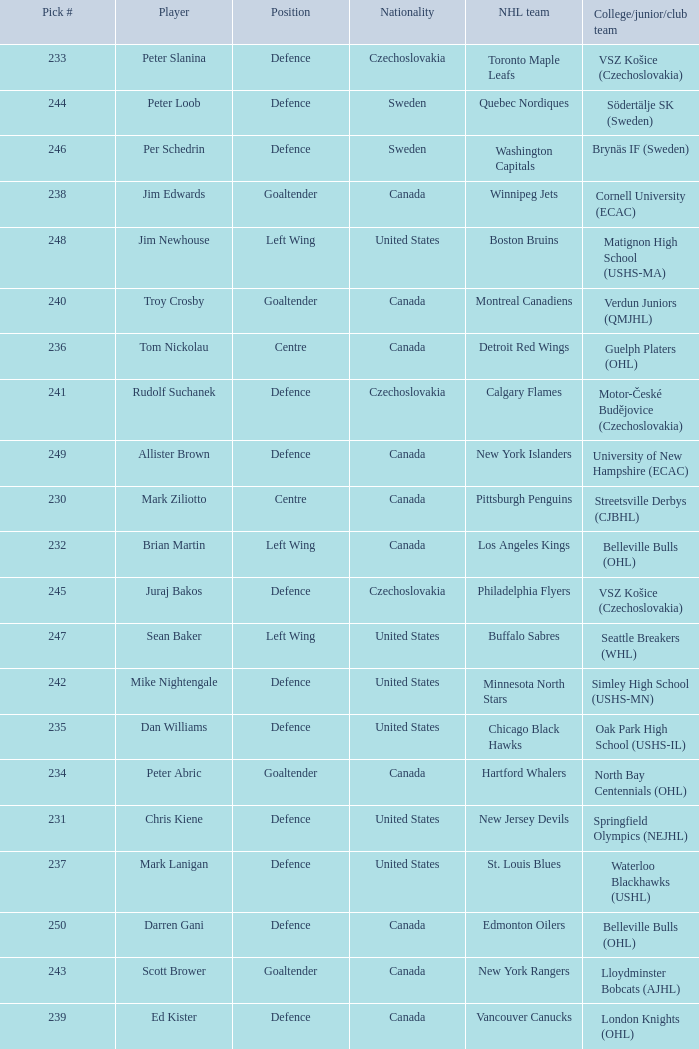What position does allister brown play. Defence. 